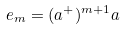Convert formula to latex. <formula><loc_0><loc_0><loc_500><loc_500>e _ { m } = ( a ^ { + } ) ^ { m + 1 } a</formula> 